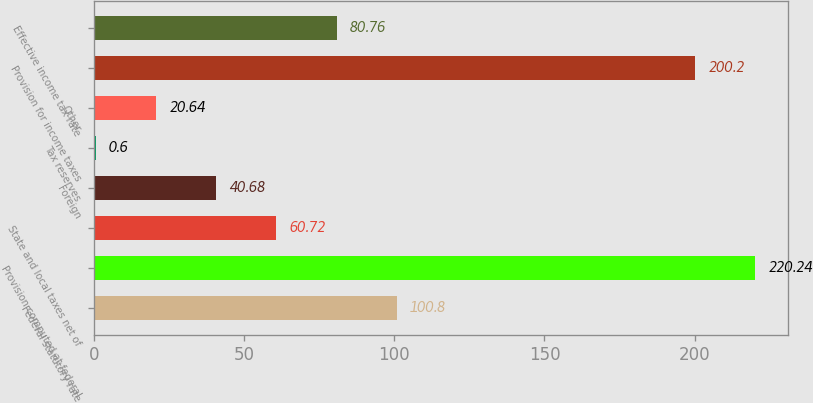Convert chart to OTSL. <chart><loc_0><loc_0><loc_500><loc_500><bar_chart><fcel>Federal statutory rate<fcel>Provision computed at federal<fcel>State and local taxes net of<fcel>Foreign<fcel>Tax reserves<fcel>Other<fcel>Provision for income taxes<fcel>Effective income tax rate<nl><fcel>100.8<fcel>220.24<fcel>60.72<fcel>40.68<fcel>0.6<fcel>20.64<fcel>200.2<fcel>80.76<nl></chart> 